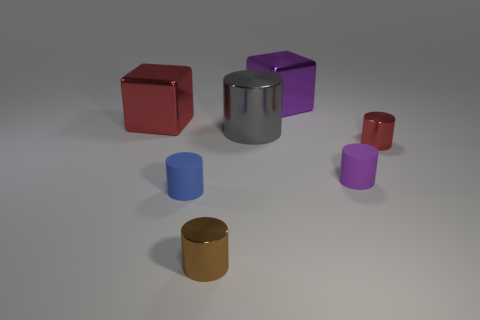Subtract all blue rubber cylinders. How many cylinders are left? 4 Subtract all cubes. How many objects are left? 5 Subtract all red cylinders. How many cylinders are left? 4 Subtract 0 red balls. How many objects are left? 7 Subtract 5 cylinders. How many cylinders are left? 0 Subtract all brown cylinders. Subtract all green blocks. How many cylinders are left? 4 Subtract all brown spheres. How many yellow blocks are left? 0 Subtract all tiny gray matte cylinders. Subtract all tiny blue matte cylinders. How many objects are left? 6 Add 3 tiny red metal cylinders. How many tiny red metal cylinders are left? 4 Add 4 big brown metal objects. How many big brown metal objects exist? 4 